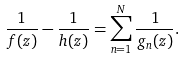<formula> <loc_0><loc_0><loc_500><loc_500>\frac { 1 } { f ( z ) } - \frac { 1 } { h ( z ) } = \sum _ { n = 1 } ^ { N } \frac { 1 } { g _ { n } ( z ) } .</formula> 